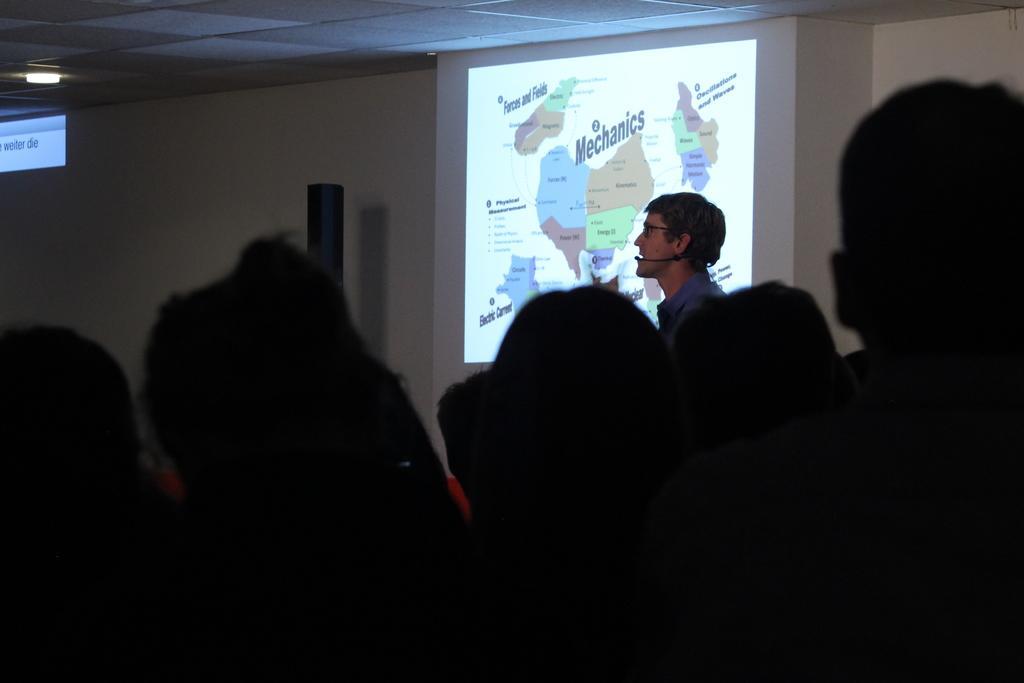Please provide a concise description of this image. In this picture I can see heads of people in front and in the background I see a projector screen on which there is something written and I see a man near it and on the left side of this image I see a light on the ceiling and I see white color thing near to it. 